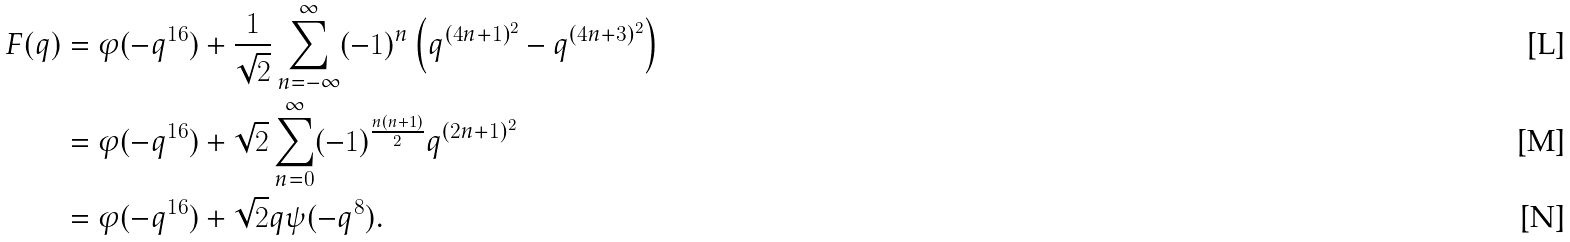Convert formula to latex. <formula><loc_0><loc_0><loc_500><loc_500>F ( q ) & = \varphi ( - q ^ { 1 6 } ) + \frac { 1 } { \sqrt { 2 } } \sum _ { n = - \infty } ^ { \infty } ( - 1 ) ^ { n } \left ( q ^ { ( 4 n + 1 ) ^ { 2 } } - q ^ { ( 4 n + 3 ) ^ { 2 } } \right ) \\ & = \varphi ( - q ^ { 1 6 } ) + \sqrt { 2 } \sum _ { n = 0 } ^ { \infty } ( - 1 ) ^ { \frac { n ( n + 1 ) } { 2 } } q ^ { ( 2 n + 1 ) ^ { 2 } } \\ & = \varphi ( - q ^ { 1 6 } ) + \sqrt { 2 } q \psi ( - q ^ { 8 } ) .</formula> 